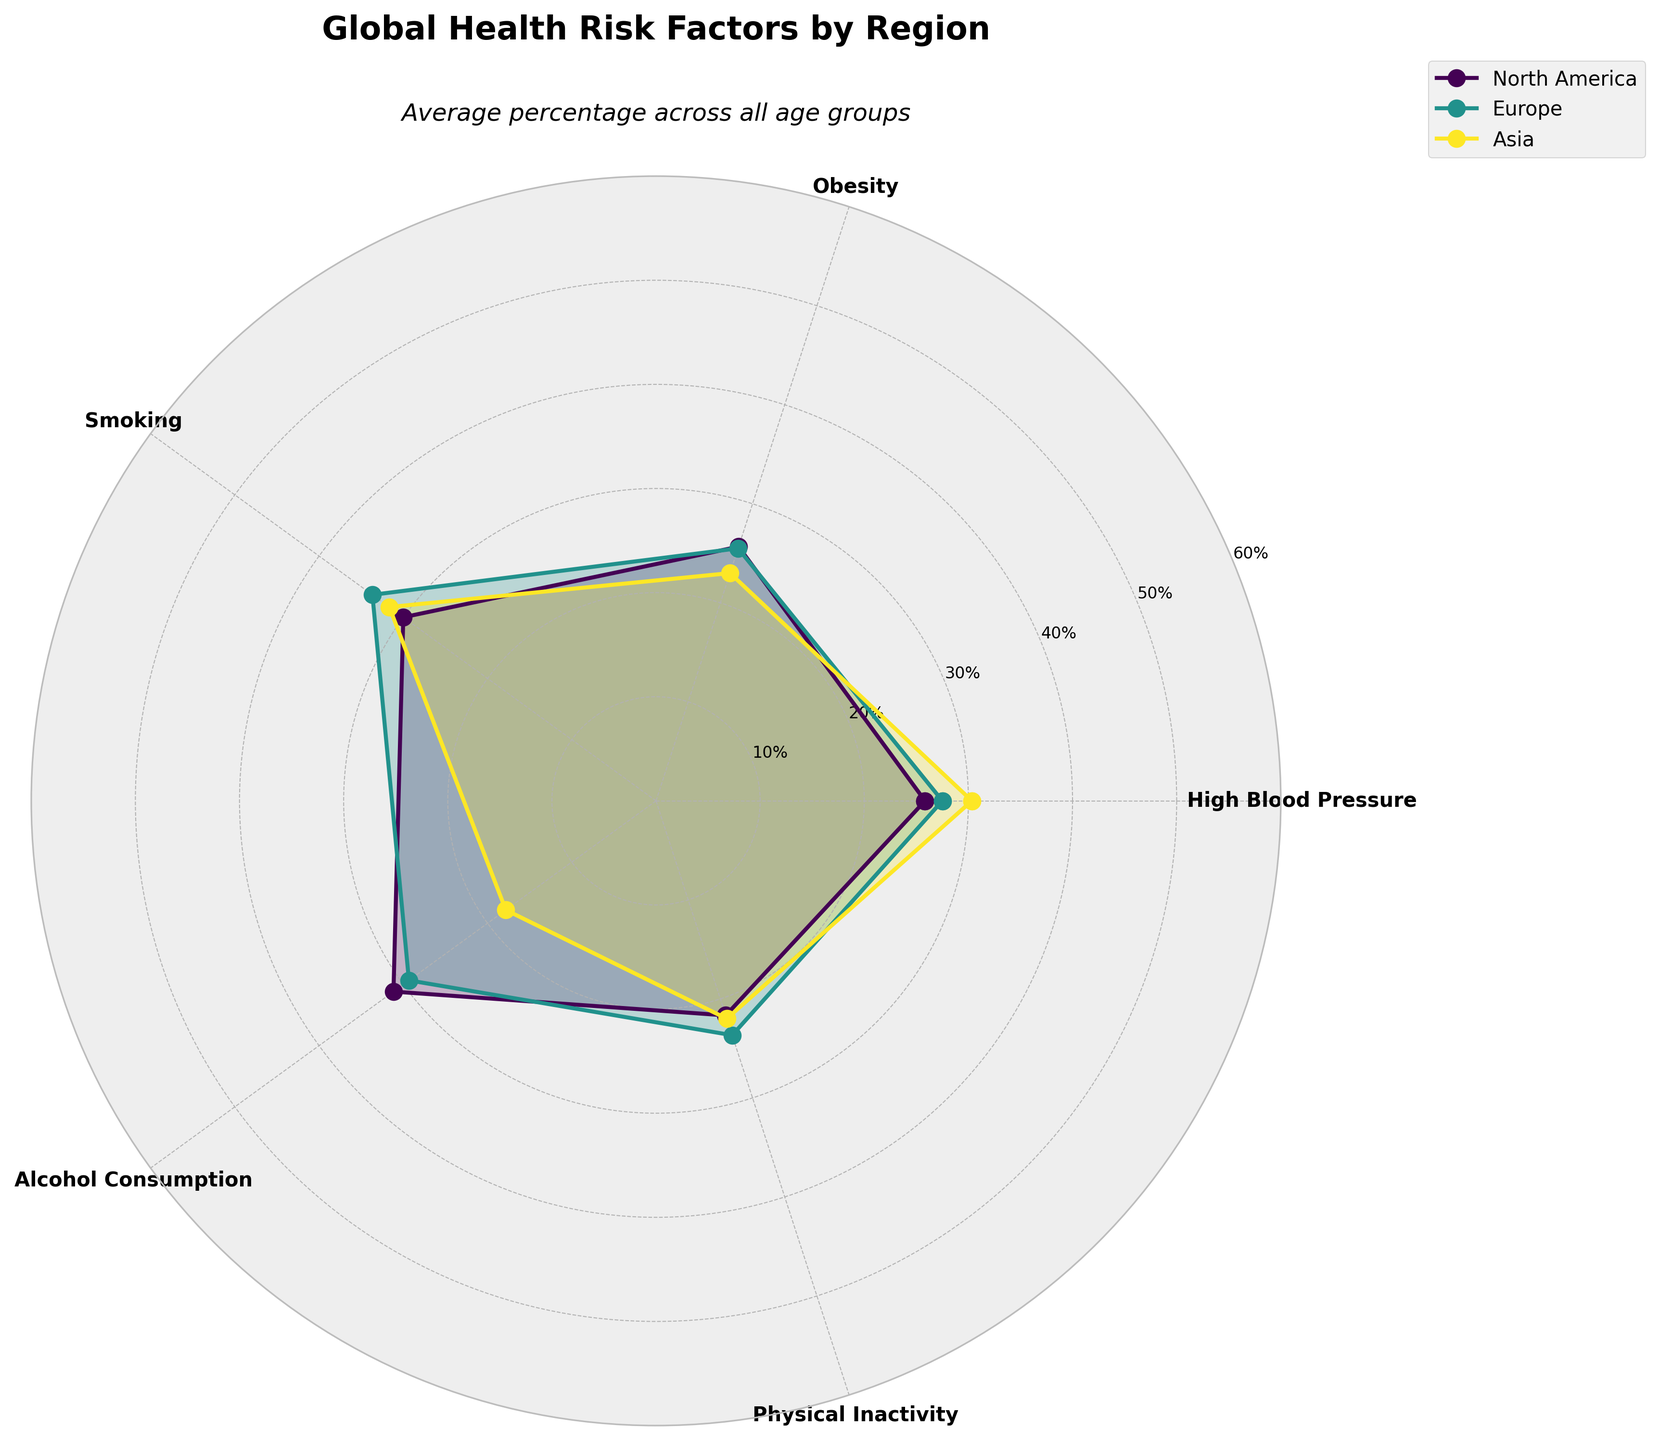What is the title of the figure? The title is displayed at the top of the figure and reads "Global Health Risk Factors by Region".
Answer: Global Health Risk Factors by Region What color represents the North America region? The colors are assigned to each region and North America is represented with the first color in the color scheme used for the plot. According to the script that utilizes the viridis colormap, this would typically be a purplish color.
Answer: Purplish Which risk factor has the highest average percentage across all regions? By comparing the values of each risk factor from the plot, we can identify that the risk factor "High Blood Pressure" has the highest average percentage across all the regions.
Answer: High Blood Pressure Do Europe and Asia have the same value for any risk factor? By examining the overlapping points or areas in the plot, we can see that Europe and Asia have the same value for the "Physical Inactivity" risk factor, which is 35%.
Answer: Yes, for "Physical Inactivity" Which region shows the highest average value for smoking? Look at the plot's values and identify which region has the highest average value for the "Smoking" category. Asia has the highest average value.
Answer: Asia What is the difference in "High Blood Pressure" between North America and Asia? North America's average value for "High Blood Pressure" is 27.5% (mean of values for North America). Asia's average value is 30%. The difference is 30% - 27.5% = 2.5%.
Answer: 2.5% Which age group has the highest "Obesity" rate in Europe? By examining the plot closely, we can see that the "Obesity" rate peaks for the age group 35-44 in Europe.
Answer: 35-44 What is the average alcohol consumption rate for the 55-64 age group across all regions? Calculate the average from the given values: (40+38+25)/3. The total is 103, and the average is 103/3 ≈ 34.33%.
Answer: 34.33% Does any region's "Physical Inactivity" values form a perfect circle when connected on the polar area plot? Check for regions where values are identical across all age groups for "Physical Inactivity". None form a perfect circle due to varying values.
Answer: No Which risk factor has the smallest range of values across all regions? By inspecting the plot, "Obesity" has the smallest range of values, varying least between different regions.
Answer: Obesity 